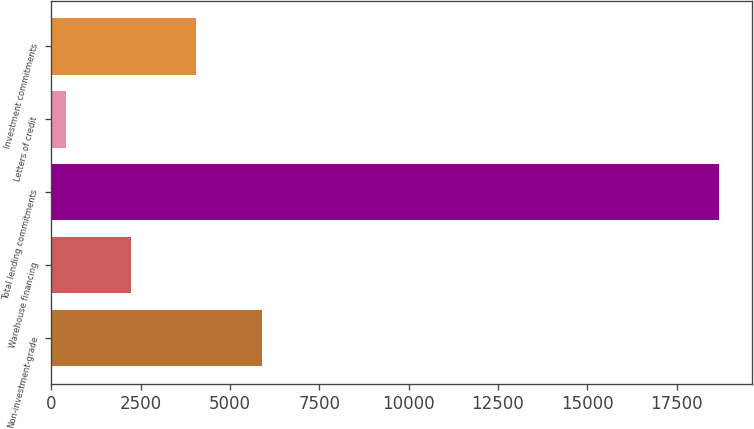<chart> <loc_0><loc_0><loc_500><loc_500><bar_chart><fcel>Non-investment-grade<fcel>Warehouse financing<fcel>Total lending commitments<fcel>Letters of credit<fcel>Investment commitments<nl><fcel>5885.9<fcel>2229.3<fcel>18684<fcel>401<fcel>4057.6<nl></chart> 